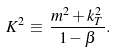<formula> <loc_0><loc_0><loc_500><loc_500>K ^ { 2 } \, \equiv \, \frac { m ^ { 2 } + k _ { T } ^ { 2 } } { 1 - \beta } .</formula> 